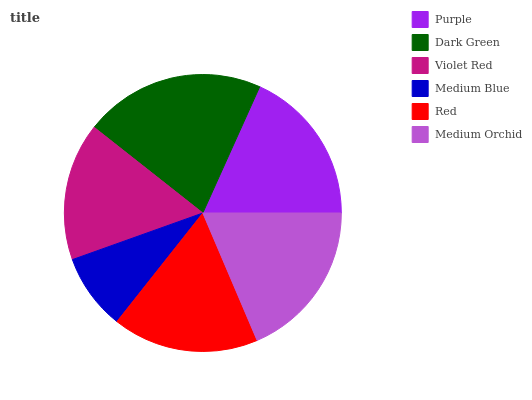Is Medium Blue the minimum?
Answer yes or no. Yes. Is Dark Green the maximum?
Answer yes or no. Yes. Is Violet Red the minimum?
Answer yes or no. No. Is Violet Red the maximum?
Answer yes or no. No. Is Dark Green greater than Violet Red?
Answer yes or no. Yes. Is Violet Red less than Dark Green?
Answer yes or no. Yes. Is Violet Red greater than Dark Green?
Answer yes or no. No. Is Dark Green less than Violet Red?
Answer yes or no. No. Is Purple the high median?
Answer yes or no. Yes. Is Red the low median?
Answer yes or no. Yes. Is Medium Orchid the high median?
Answer yes or no. No. Is Dark Green the low median?
Answer yes or no. No. 